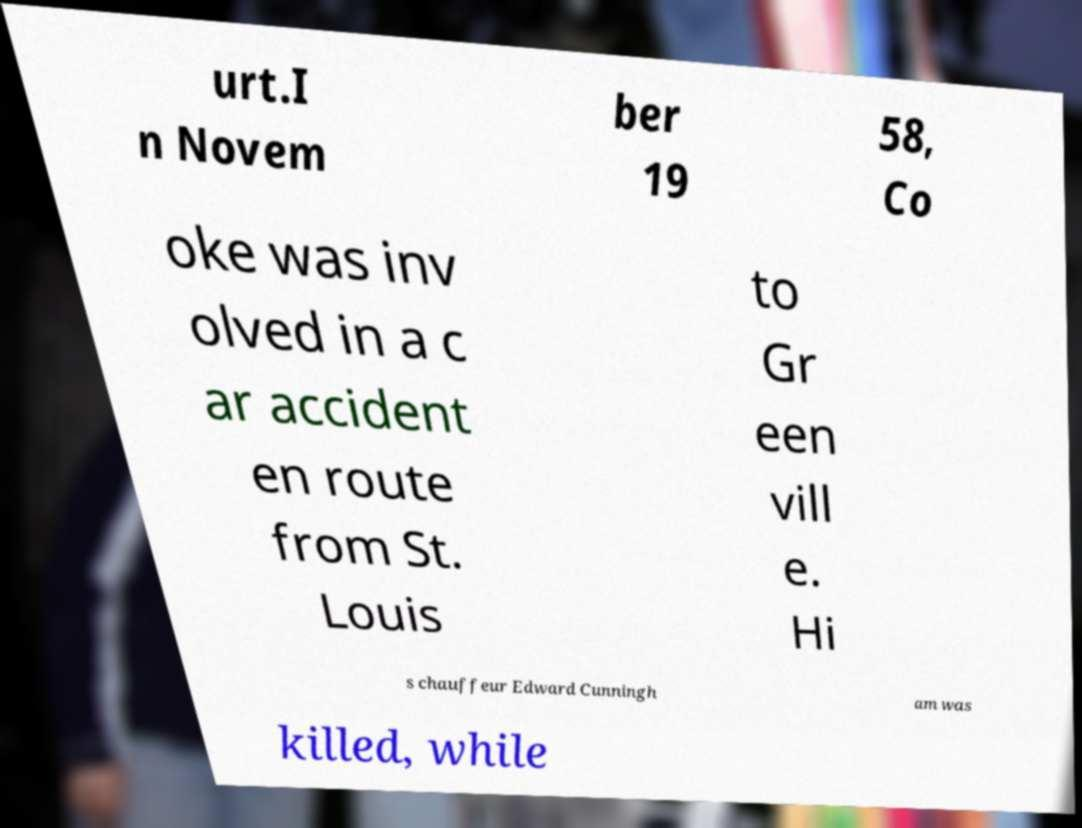For documentation purposes, I need the text within this image transcribed. Could you provide that? urt.I n Novem ber 19 58, Co oke was inv olved in a c ar accident en route from St. Louis to Gr een vill e. Hi s chauffeur Edward Cunningh am was killed, while 